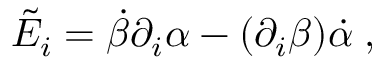Convert formula to latex. <formula><loc_0><loc_0><loc_500><loc_500>\tilde { E } _ { i } = \dot { \beta } \partial _ { i } \alpha - ( \partial _ { i } \beta ) \dot { \alpha } \, ,</formula> 